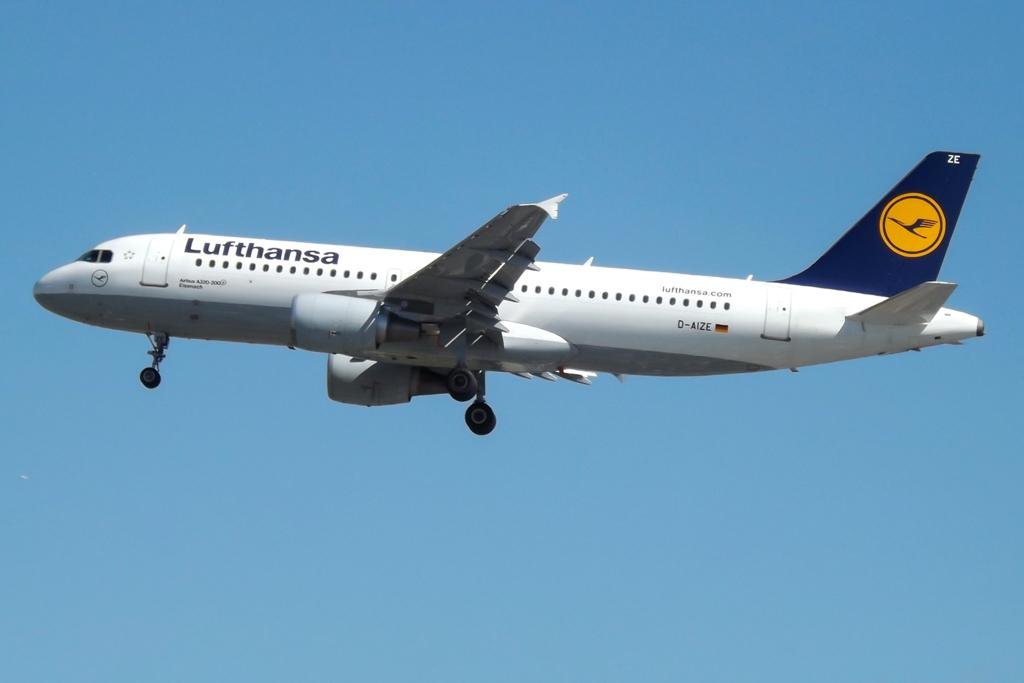What airliner is this plane from?
Keep it short and to the point. Lufthansa. 